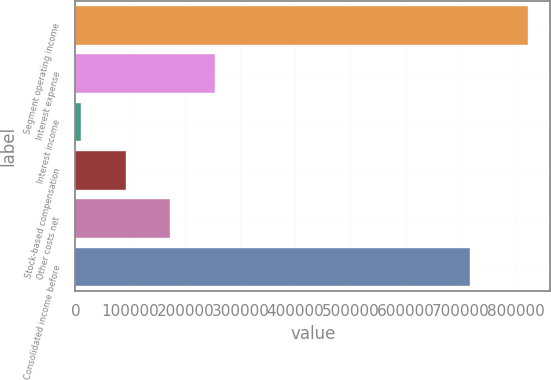Convert chart to OTSL. <chart><loc_0><loc_0><loc_500><loc_500><bar_chart><fcel>Segment operating income<fcel>Interest expense<fcel>Interest income<fcel>Stock-based compensation<fcel>Other costs net<fcel>Consolidated income before<nl><fcel>822136<fcel>253812<fcel>10245<fcel>91434.1<fcel>172623<fcel>716752<nl></chart> 